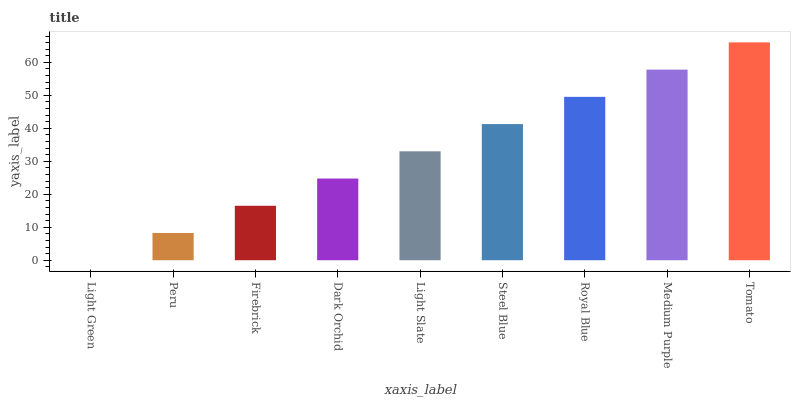Is Peru the minimum?
Answer yes or no. No. Is Peru the maximum?
Answer yes or no. No. Is Peru greater than Light Green?
Answer yes or no. Yes. Is Light Green less than Peru?
Answer yes or no. Yes. Is Light Green greater than Peru?
Answer yes or no. No. Is Peru less than Light Green?
Answer yes or no. No. Is Light Slate the high median?
Answer yes or no. Yes. Is Light Slate the low median?
Answer yes or no. Yes. Is Dark Orchid the high median?
Answer yes or no. No. Is Dark Orchid the low median?
Answer yes or no. No. 